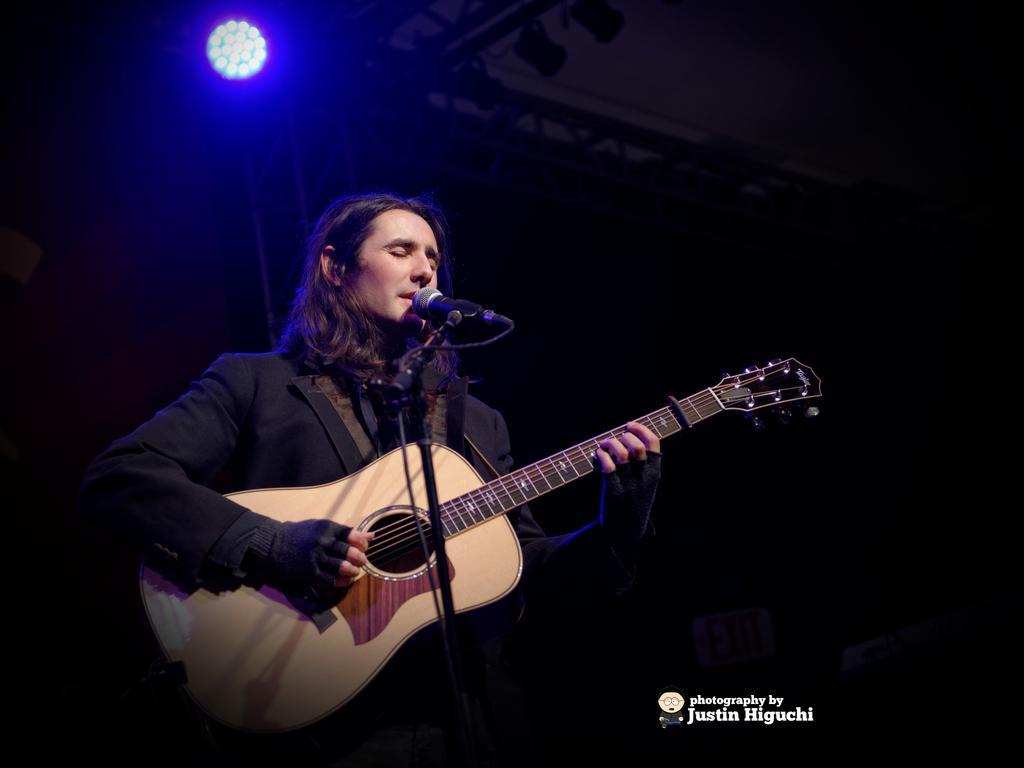In one or two sentences, can you explain what this image depicts? In this picture we can see man singing on mic and holding guitar in his hand and playing and in the background we can see light and it is blurry. 